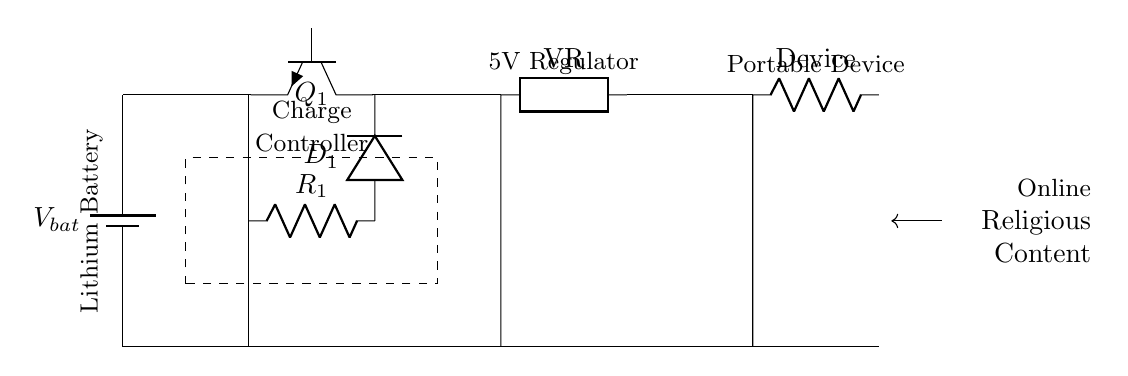What type of battery is used in this circuit? The circuit shows a lithium battery connected as the power source. This is indicated by the label on the battery component in the diagram.
Answer: Lithium battery What does the component labeled D1 do? D1 is a diode that allows current to flow in one direction, preventing reverse flow. Its function is essential in protecting the circuit from potential damage caused by reverse voltage.
Answer: Diode What voltage does the voltage regulator output? The circuit is designed to regulate the output voltage to 5 volts, as indicated by the labeling on the voltage regulator component.
Answer: 5 volts Which component controls the charging of the battery? The component Q1, labeled as a transistor, acts as a switch and controlling element for charging the battery by regulating the on-off states based on the specific conditions.
Answer: Q1 What is the load in this circuit? The load is represented as a device connected to the circuit, specifically mentioned in the diagram as the "Device" that consumes power regulated by the circuit.
Answer: Portable device How does the charge controller interact with the battery? The charge controller regulates the charging process, ensuring that the lithium battery receives the correct voltage and current while preventing overcharging, which is crucial for battery safety and longevity.
Answer: Regulates charging What external source is implied for content access? The diagram indicates that there is an online source of religious content, portrayed as an arrow pointing toward the device, suggesting the device's use for accessing information.
Answer: Online religious content 